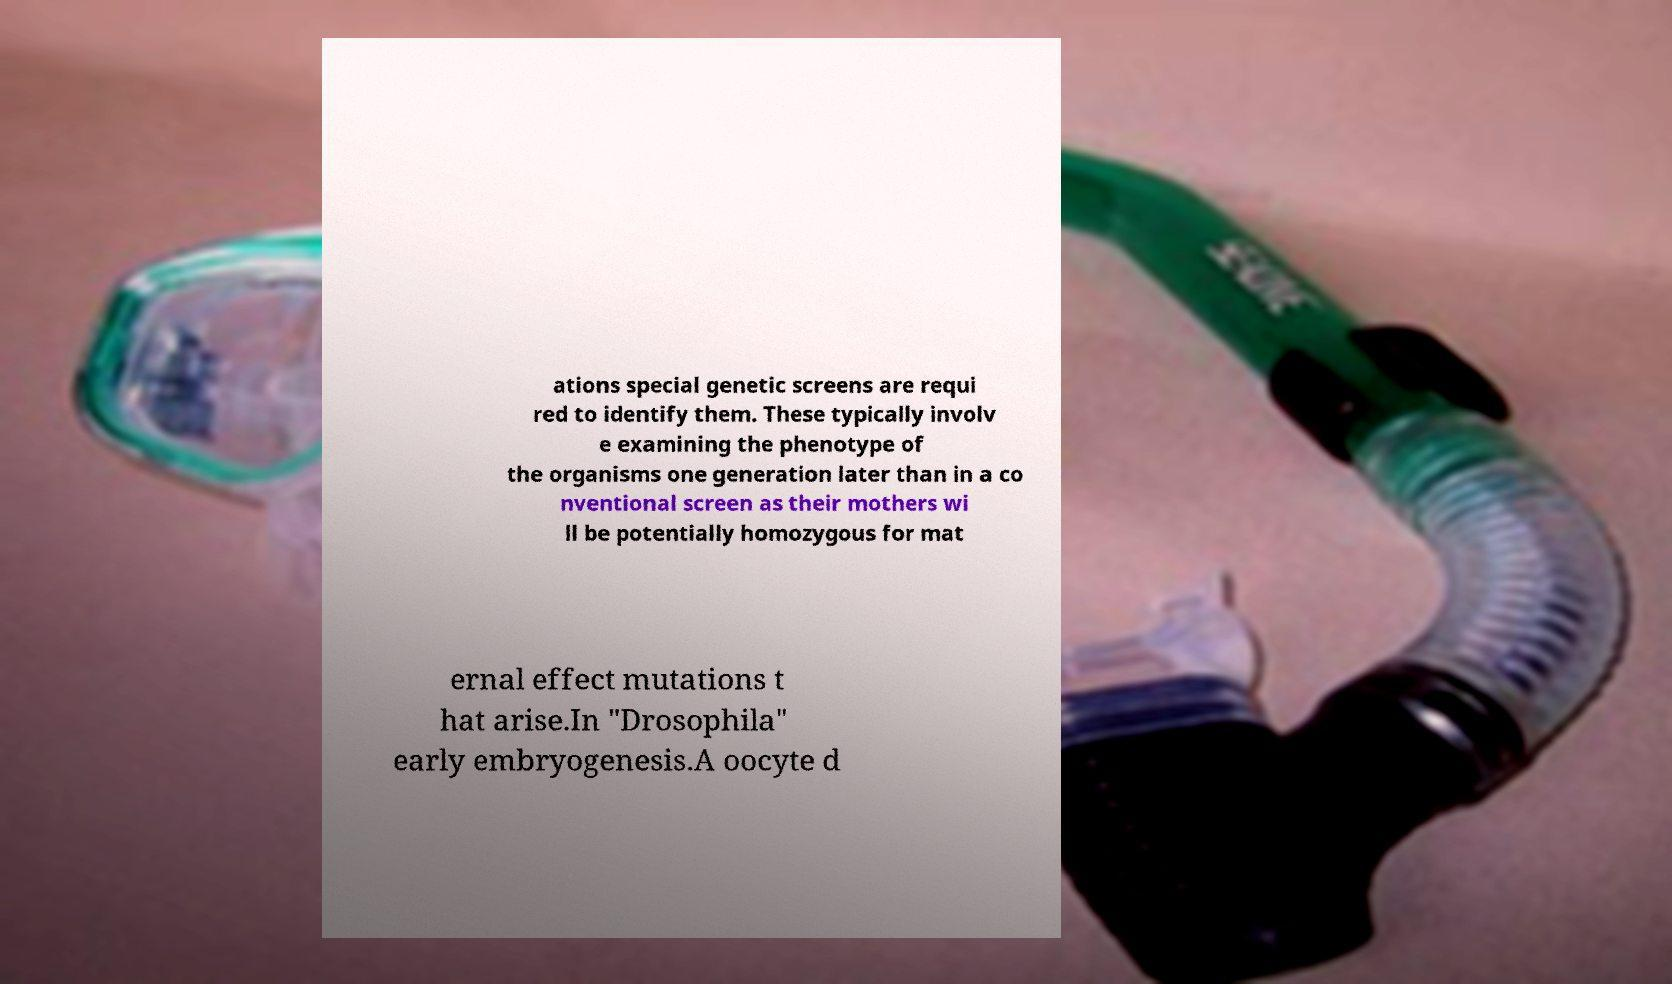Please identify and transcribe the text found in this image. ations special genetic screens are requi red to identify them. These typically involv e examining the phenotype of the organisms one generation later than in a co nventional screen as their mothers wi ll be potentially homozygous for mat ernal effect mutations t hat arise.In "Drosophila" early embryogenesis.A oocyte d 